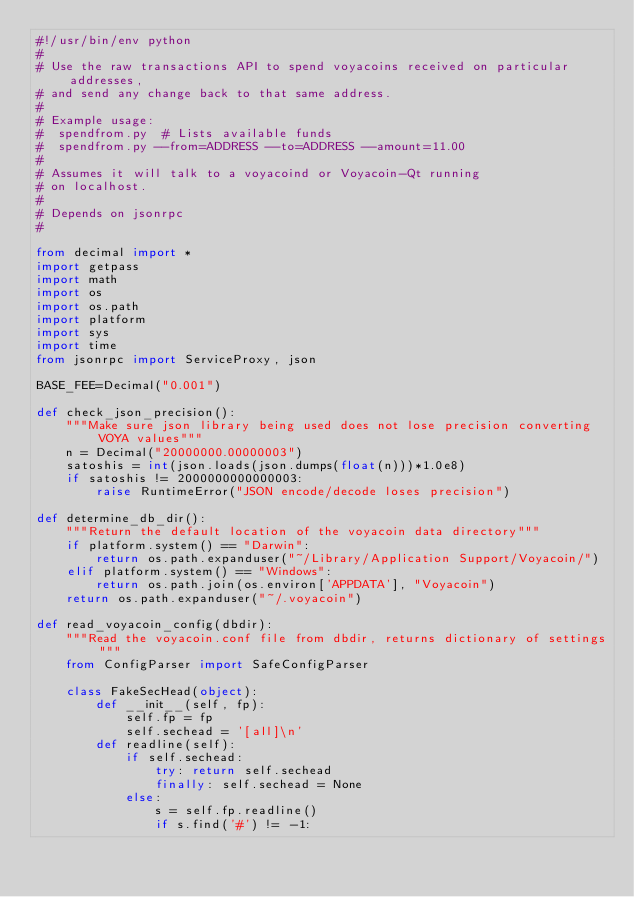Convert code to text. <code><loc_0><loc_0><loc_500><loc_500><_Python_>#!/usr/bin/env python
#
# Use the raw transactions API to spend voyacoins received on particular addresses,
# and send any change back to that same address.
#
# Example usage:
#  spendfrom.py  # Lists available funds
#  spendfrom.py --from=ADDRESS --to=ADDRESS --amount=11.00
#
# Assumes it will talk to a voyacoind or Voyacoin-Qt running
# on localhost.
#
# Depends on jsonrpc
#

from decimal import *
import getpass
import math
import os
import os.path
import platform
import sys
import time
from jsonrpc import ServiceProxy, json

BASE_FEE=Decimal("0.001")

def check_json_precision():
    """Make sure json library being used does not lose precision converting VOYA values"""
    n = Decimal("20000000.00000003")
    satoshis = int(json.loads(json.dumps(float(n)))*1.0e8)
    if satoshis != 2000000000000003:
        raise RuntimeError("JSON encode/decode loses precision")

def determine_db_dir():
    """Return the default location of the voyacoin data directory"""
    if platform.system() == "Darwin":
        return os.path.expanduser("~/Library/Application Support/Voyacoin/")
    elif platform.system() == "Windows":
        return os.path.join(os.environ['APPDATA'], "Voyacoin")
    return os.path.expanduser("~/.voyacoin")

def read_voyacoin_config(dbdir):
    """Read the voyacoin.conf file from dbdir, returns dictionary of settings"""
    from ConfigParser import SafeConfigParser

    class FakeSecHead(object):
        def __init__(self, fp):
            self.fp = fp
            self.sechead = '[all]\n'
        def readline(self):
            if self.sechead:
                try: return self.sechead
                finally: self.sechead = None
            else:
                s = self.fp.readline()
                if s.find('#') != -1:</code> 